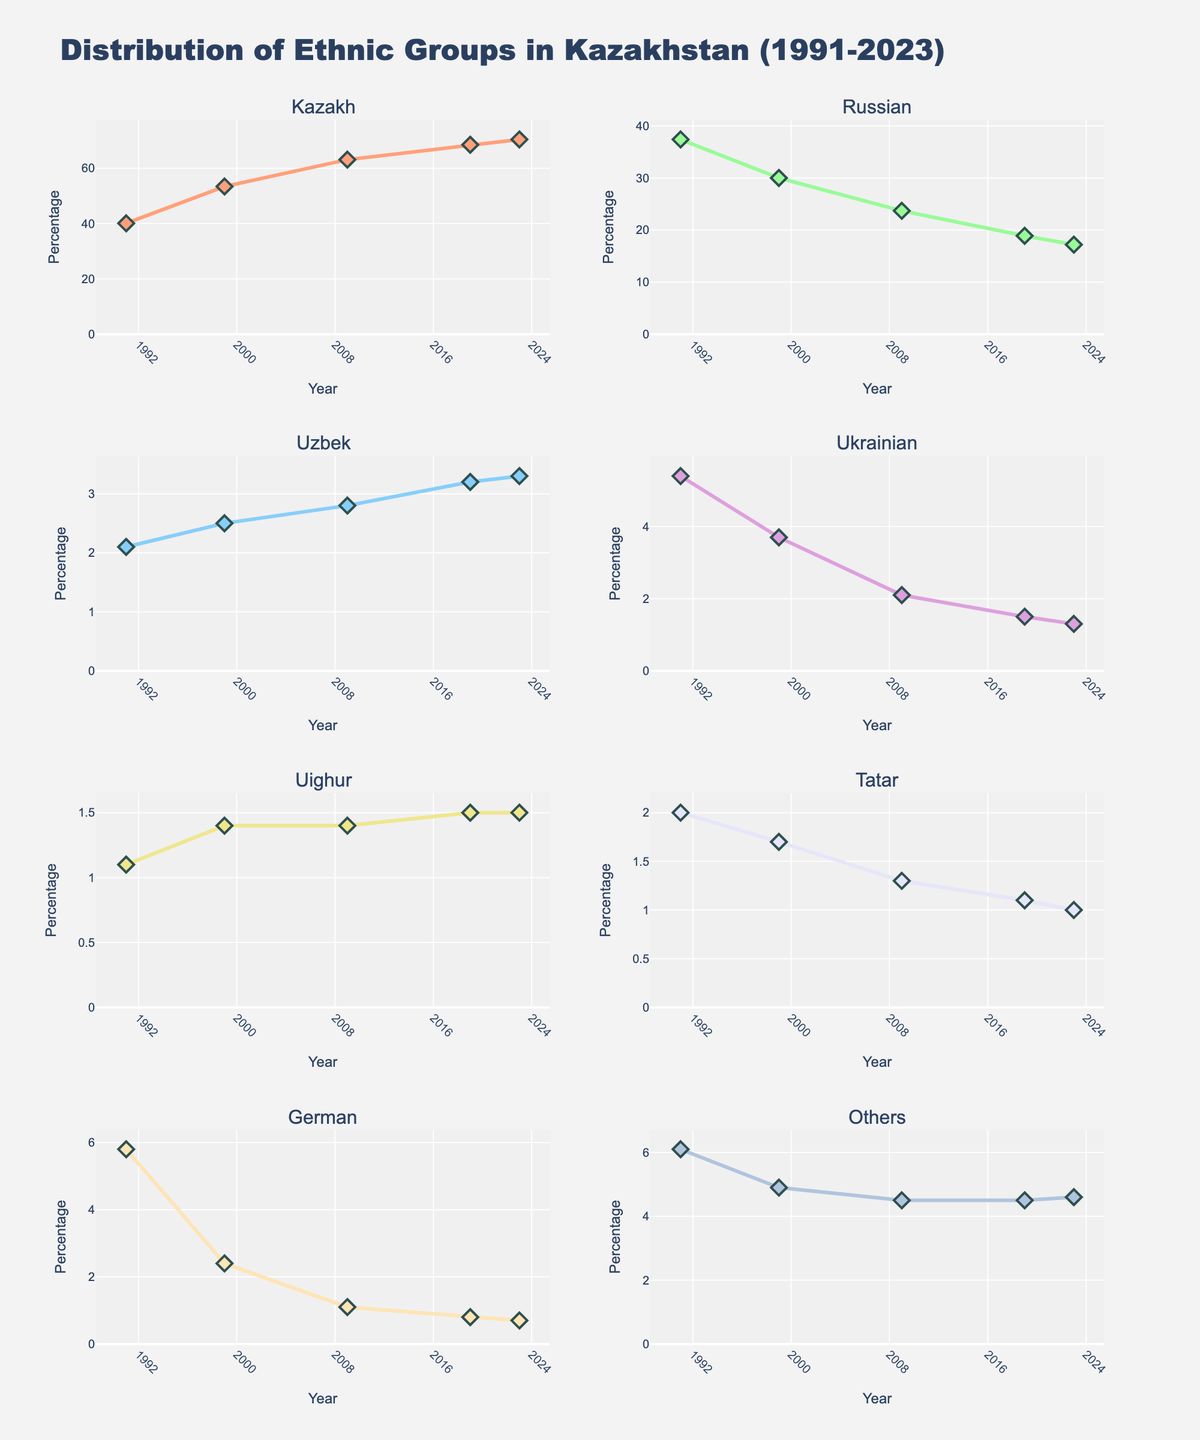What's the title of the figure? The title of the figure is displayed at the top of the subplot grid.
Answer: Distribution of Ethnic Groups in Kazakhstan (1991-2023) What does the x-axis represent in all subplots? The x-axis in all subplots represents the years from 1991 to 2023.
Answer: Year Which ethnic group had the highest percentage in 1999? By looking at the 1999 data points, the ethnic group with the highest percentage is the Kazakhs.
Answer: Kazakh How does the Tatar population trend over time? The Tatar population percentage decreases slightly over time, from 2.0% in 1991 to 1.0% in 2023.
Answer: Decreasing What is the percentage change for the Russian population from 1991 to 2023? The initial Russian population was 37.4% in 1991 and decreased to 17.2% in 2023. The change is 37.4 - 17.2 = 20.2%.
Answer: 20.2% In which year did the Ukrainian population percentage drop below 2%? By examining the Ukrainian plots, the percentage went below 2% in 2009.
Answer: 2009 Which ethnic group showed the most stability in their population percentage over the years? By comparing all ethnic groups, the Uighur population shows the least fluctuation, staying around 1.1% to 1.5%.
Answer: Uighur What is the approximate average percentage of the Kazakh population over the years? Sum of Kazakh percentages from 1991, 1999, 2009, 2019, 2023: 40.1 + 53.4 + 63.1 + 68.5 + 70.4 = 295.5. The average = 295.5 / 5.
Answer: 59.1% Which group experienced the largest percentage decline from 1991 to 2023? Comparing initial and final values for each group, the German population decreased the most, from 5.8% to 0.7%, a decline of 5.1%.
Answer: German 